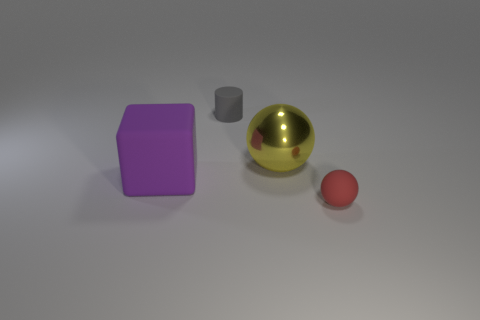There is a red thing that is the same material as the big purple cube; what shape is it?
Your answer should be very brief. Sphere. What material is the sphere behind the small sphere?
Keep it short and to the point. Metal. How big is the rubber thing behind the big thing behind the large rubber thing?
Keep it short and to the point. Small. Are there more tiny matte things on the left side of the yellow shiny ball than large gray matte objects?
Offer a terse response. Yes. Does the object that is behind the yellow sphere have the same size as the small red object?
Your response must be concise. Yes. What color is the matte thing that is both in front of the gray cylinder and on the right side of the purple thing?
Ensure brevity in your answer.  Red. There is a matte thing that is the same size as the red ball; what is its shape?
Provide a short and direct response. Cylinder. Are there an equal number of large metal things that are behind the shiny sphere and large metallic balls?
Provide a succinct answer. No. There is a object that is both on the right side of the large rubber object and left of the yellow metal object; how big is it?
Provide a short and direct response. Small. The cylinder that is the same material as the large purple thing is what color?
Offer a very short reply. Gray. 